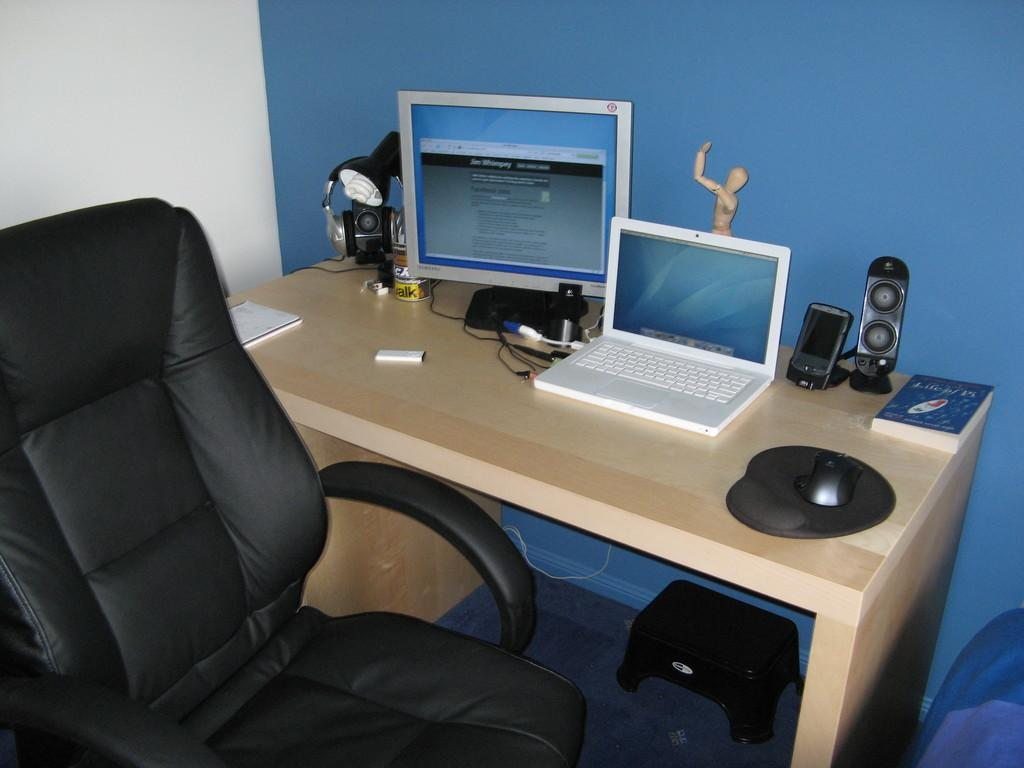What color is the wall in the image? The wall in the image is blue. What type of furniture is present in the image? There is a chair and a table in the image. What electronic device is on the table? There is a laptop on the table. What other items are on the table? There is a screen, a light, a camera, a mouse, and a book on the table. Is there a bed in the image? No, there is no bed present in the image. 